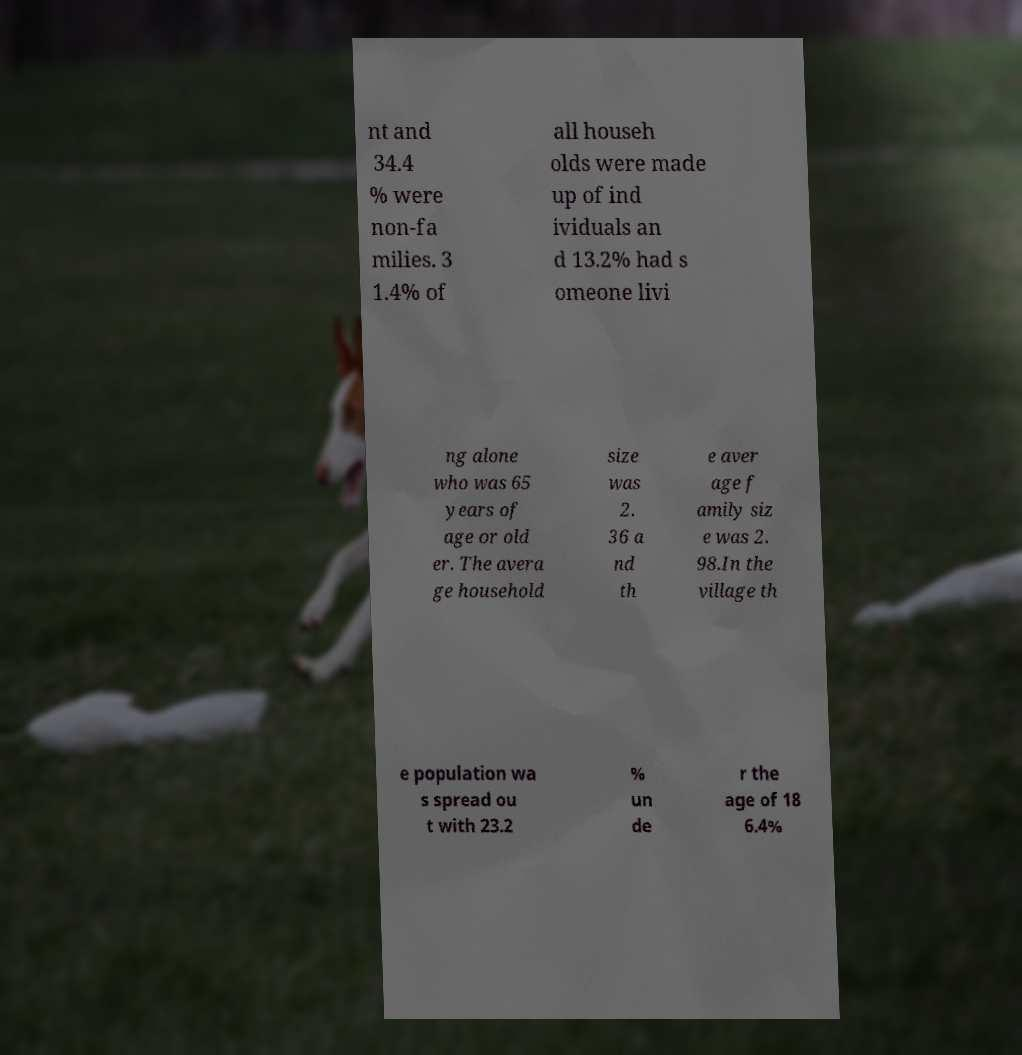I need the written content from this picture converted into text. Can you do that? nt and 34.4 % were non-fa milies. 3 1.4% of all househ olds were made up of ind ividuals an d 13.2% had s omeone livi ng alone who was 65 years of age or old er. The avera ge household size was 2. 36 a nd th e aver age f amily siz e was 2. 98.In the village th e population wa s spread ou t with 23.2 % un de r the age of 18 6.4% 